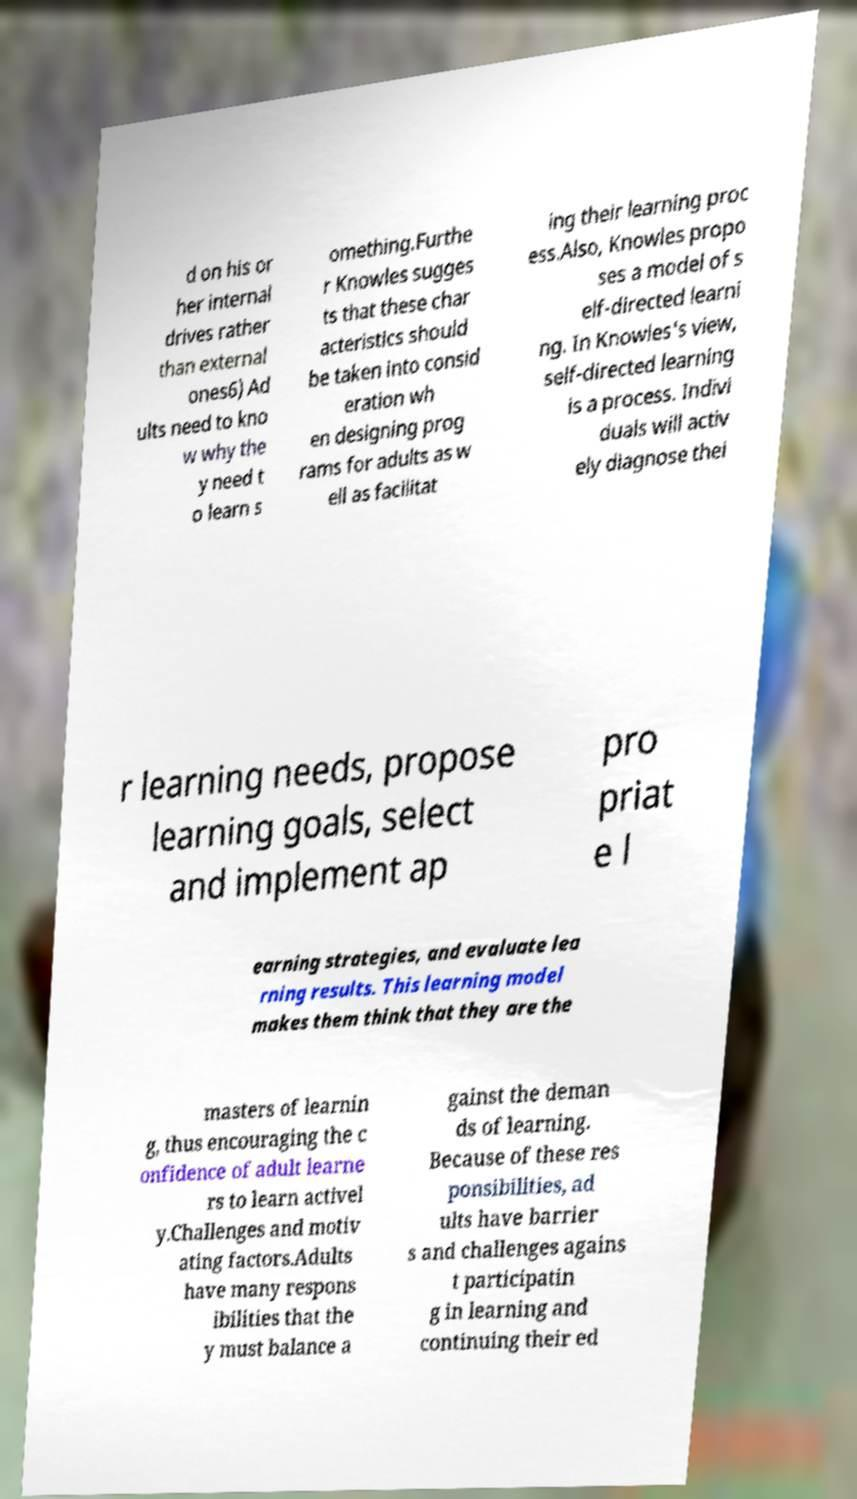Could you extract and type out the text from this image? d on his or her internal drives rather than external ones6) Ad ults need to kno w why the y need t o learn s omething.Furthe r Knowles sugges ts that these char acteristics should be taken into consid eration wh en designing prog rams for adults as w ell as facilitat ing their learning proc ess.Also, Knowles propo ses a model of s elf-directed learni ng. In Knowles's view, self-directed learning is a process. Indivi duals will activ ely diagnose thei r learning needs, propose learning goals, select and implement ap pro priat e l earning strategies, and evaluate lea rning results. This learning model makes them think that they are the masters of learnin g, thus encouraging the c onfidence of adult learne rs to learn activel y.Challenges and motiv ating factors.Adults have many respons ibilities that the y must balance a gainst the deman ds of learning. Because of these res ponsibilities, ad ults have barrier s and challenges agains t participatin g in learning and continuing their ed 